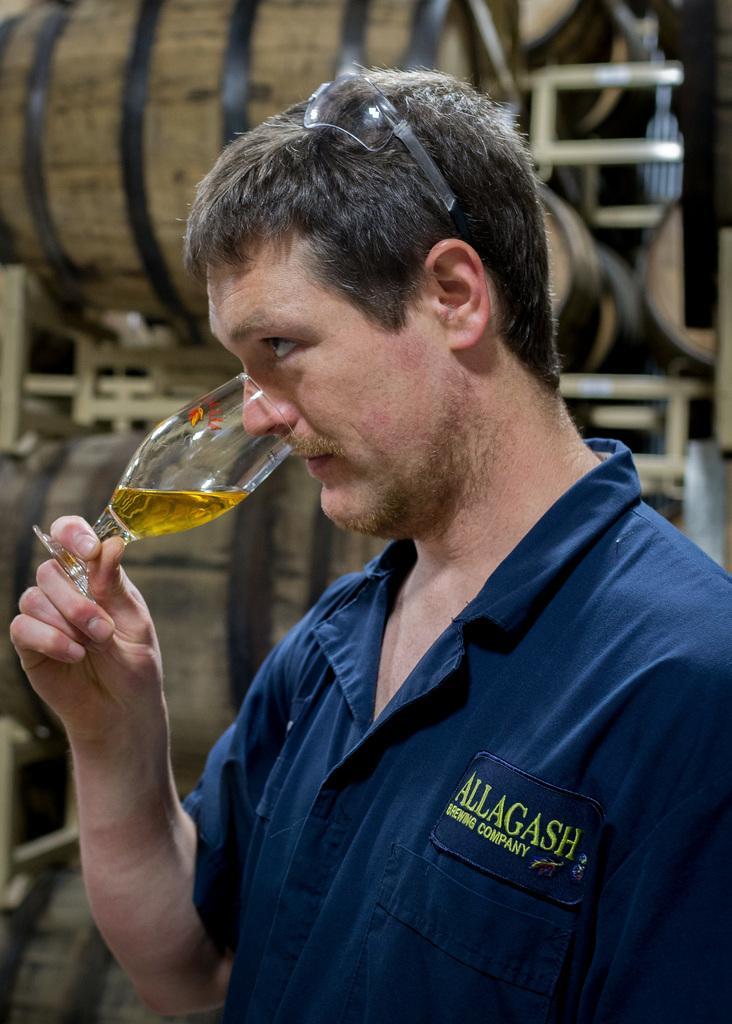Please provide a concise description of this image. In this picture I can see a man is holding a glass in the hand. In the background I can see wooden barrels. 